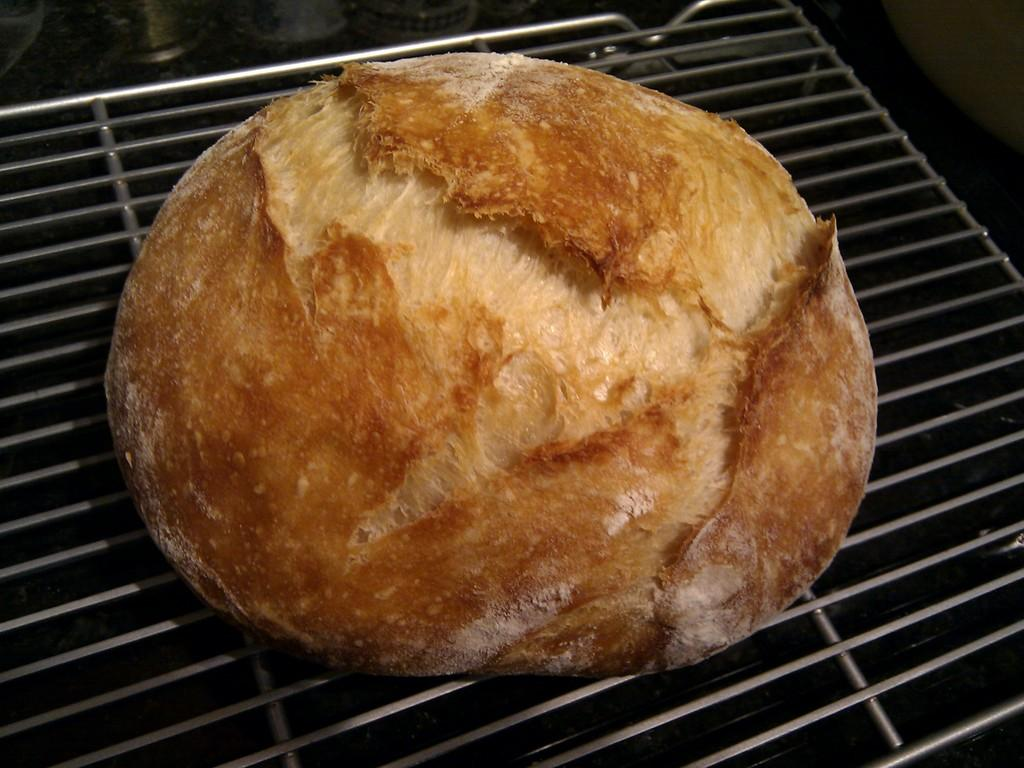What is the main subject of the image? The main subject of the image is food on a metal object. Can you describe any objects located towards the top of the image? There are objects towards the top of the image, but their specific details are not mentioned in the facts. What can be observed about the background of the image? The background of the image is dark. What type of string is being used to tie the berries together in the image? There is no mention of berries or string in the image, so it cannot be determined from the facts. 